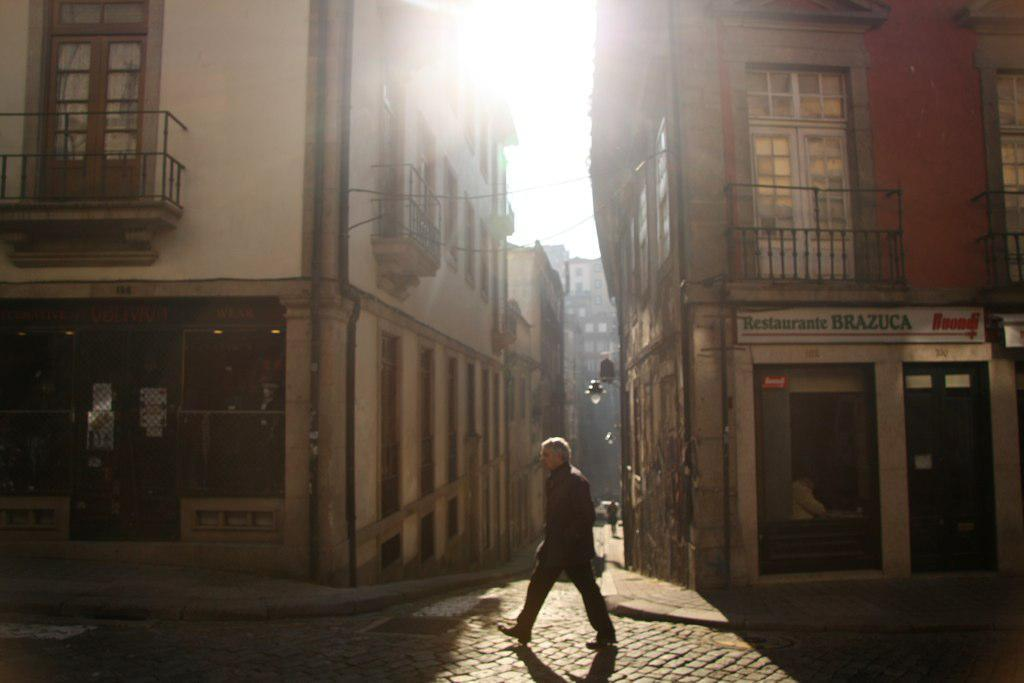What is the main subject of the image? There is a person walking in the image. What can be seen in the background of the image? There are buildings in the background of the image. What features do the buildings have? The buildings have windows, doors, and balconies. Is there any additional detail about the buildings? Yes, there is a light on the wall of one of the buildings. What type of insect can be seen crawling on the person's shoulder in the image? There is no insect visible on the person's shoulder in the image. Is there a spy observing the person walking in the image? There is no indication of a spy in the image; it only shows a person walking and buildings in the background. 